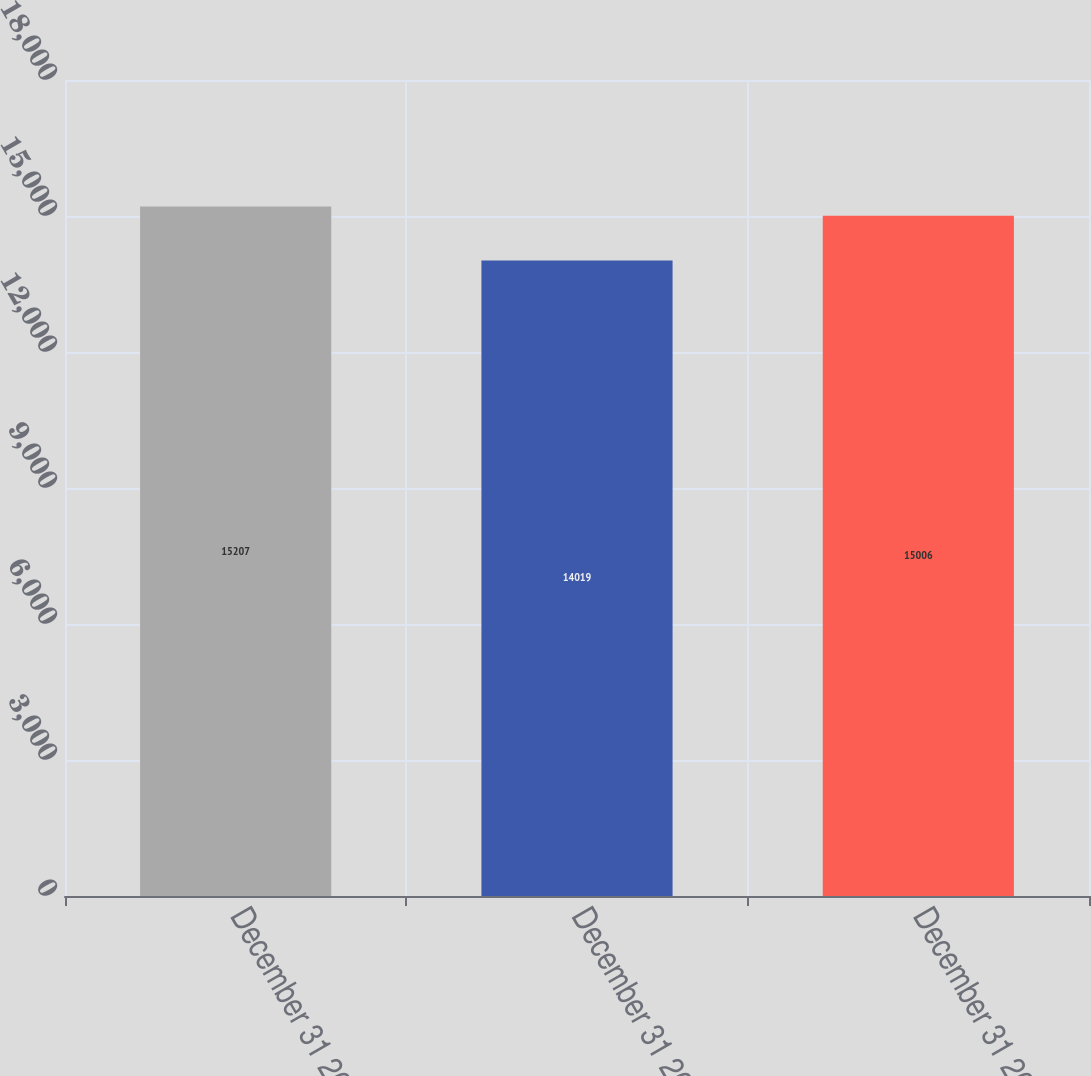Convert chart to OTSL. <chart><loc_0><loc_0><loc_500><loc_500><bar_chart><fcel>December 31 2008<fcel>December 31 2007<fcel>December 31 2006<nl><fcel>15207<fcel>14019<fcel>15006<nl></chart> 